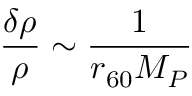<formula> <loc_0><loc_0><loc_500><loc_500>{ \frac { \delta \rho } { \rho } } \sim { \frac { 1 } { r _ { 6 0 } M _ { P } } }</formula> 